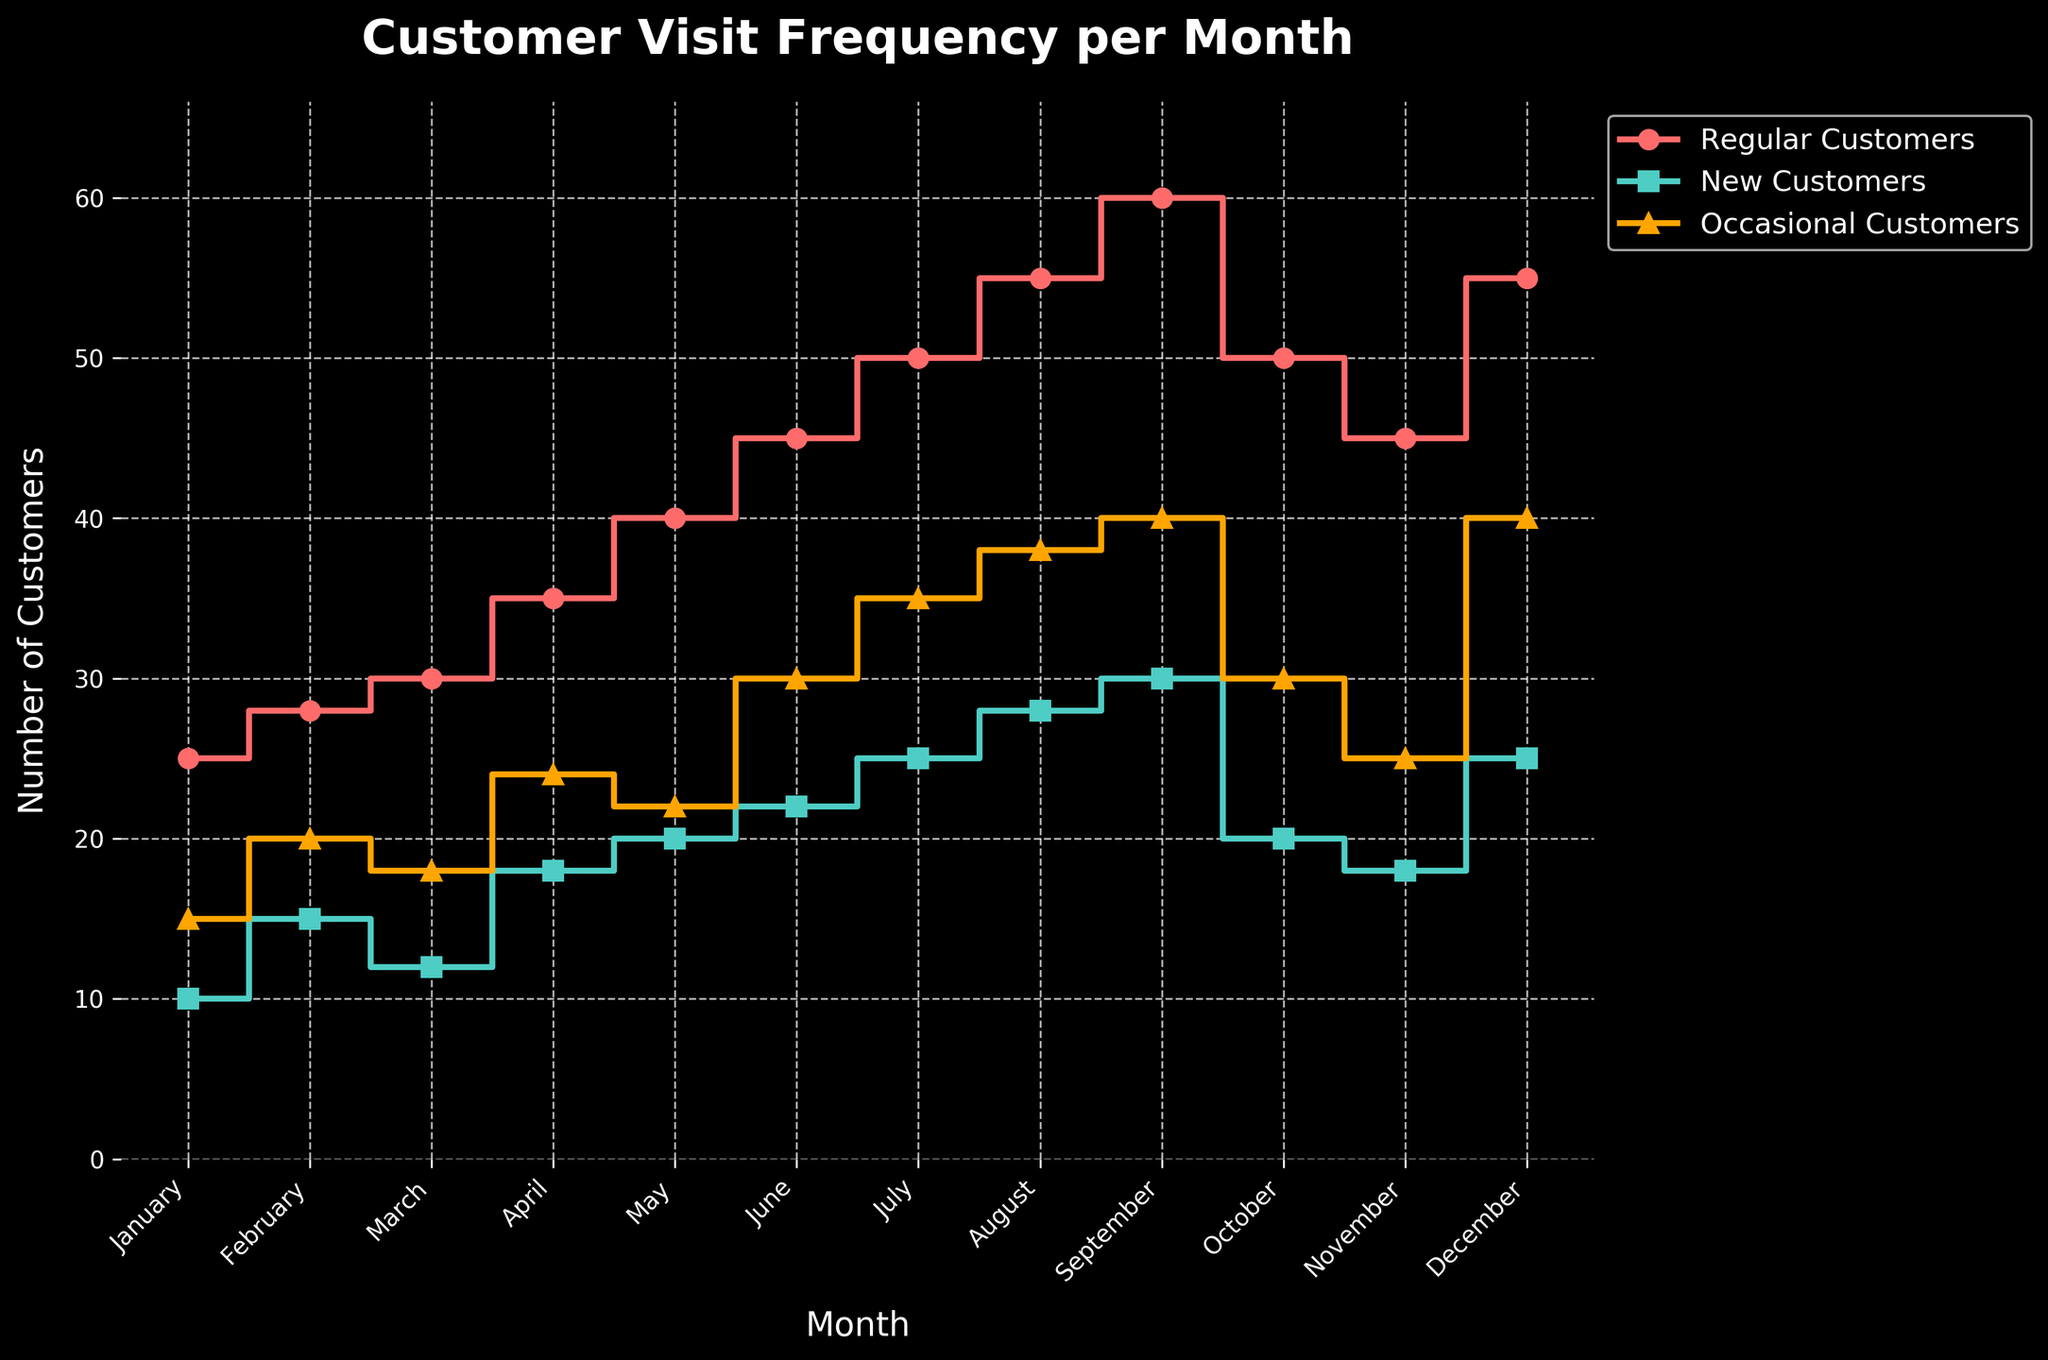Which month saw the highest number of regular customers? From the figure, the peak for regular customers occurs at the highest point of the red step line. This peak is in September.
Answer: September How do the number of new customers in January compare to those in December? The figure shows that in January, new customers are represented at 10 where the teal step line starts, and in December, this line ends at 25. So, new customers in December are higher than in January.
Answer: New customers in December are higher How does the number of occasional customers change from October to December? From the figure, the orange step line in October is at 30 and rises to 40 in December. Hence, the number of occasional customers increases by 10 from October to December.
Answer: Increases by 10 What's the difference between regular customers in June and new customers in February? In June, regular customers are at 45 as indicated by the red step line, and in February, new customers are at 15 as per the teal step line. The difference is 45 - 15 = 30.
Answer: 30 Which group has the most consistent number of customers throughout the year? Regular customers show a steady increase every month except for a drop in October, while new and occasional customers fluctuate more. Therefore, regular customers have the most consistent number throughout the year.
Answer: Regular customers When did the number of occasional customers surpass 30? Observing the figure, the orange step line first hits 30 in July and remains above 30 for the subsequent months.
Answer: July Are there any months when the number of new customers is equal to the number of occasional customers? Examining the teal and orange step lines, both intersect at no point throughout the year, indicating no month where their counts are equal.
Answer: No By how much did the regular customers increase from January to July? The red step line starts at 25 in January and reaches 50 in July. Thus, the increase is 50 - 25 = 25.
Answer: 25 What is the general trend for all three types of customers through the year? Regular and occasional customers show an increasing trend, while new customers also generally increase but with more fluctuations, particularly in October and November.
Answer: Increasing trends, but with fluctuations for new customers 